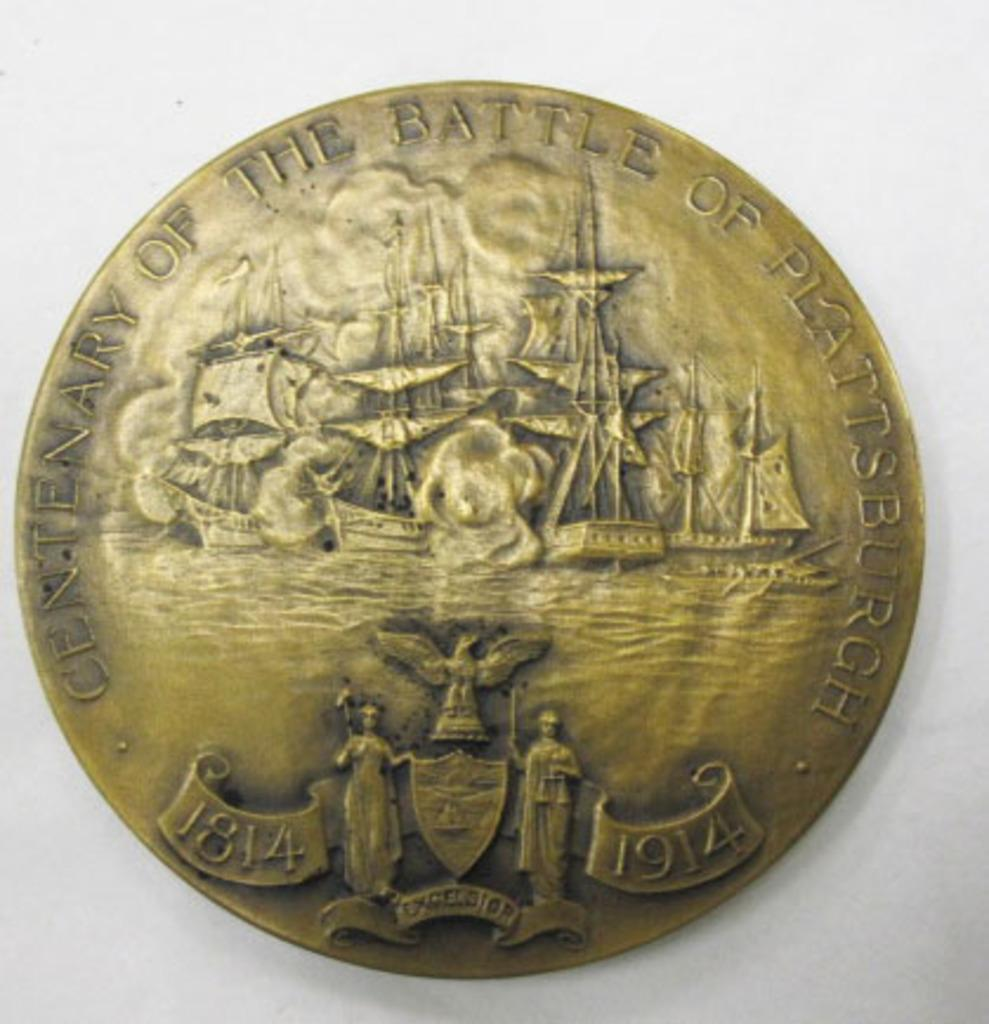Provide a one-sentence caption for the provided image. A bronze coloured coin depicts The Battle Of Plattsburgh. 